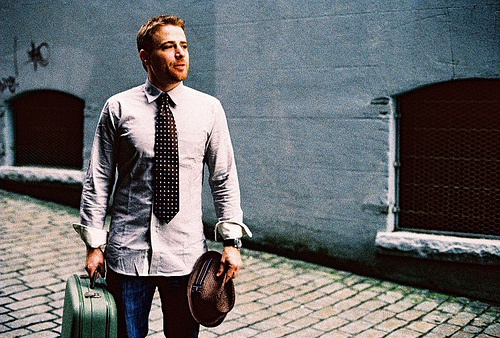Describe the objects in this image and their specific colors. I can see people in black, lightgray, darkgray, and gray tones, tie in black, gray, white, and maroon tones, and suitcase in black, lightgray, darkgray, and darkgreen tones in this image. 